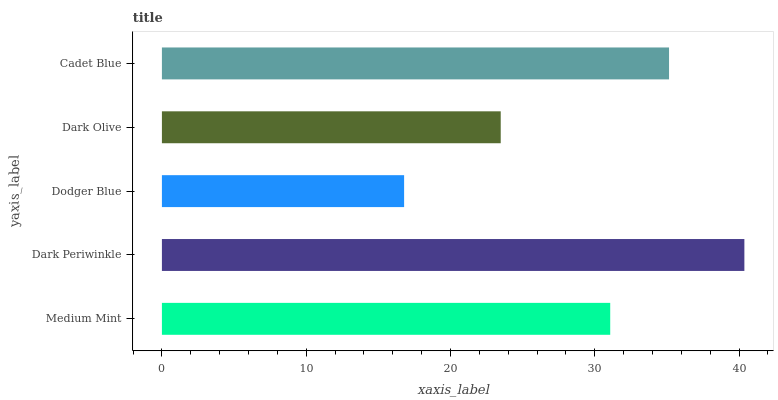Is Dodger Blue the minimum?
Answer yes or no. Yes. Is Dark Periwinkle the maximum?
Answer yes or no. Yes. Is Dark Periwinkle the minimum?
Answer yes or no. No. Is Dodger Blue the maximum?
Answer yes or no. No. Is Dark Periwinkle greater than Dodger Blue?
Answer yes or no. Yes. Is Dodger Blue less than Dark Periwinkle?
Answer yes or no. Yes. Is Dodger Blue greater than Dark Periwinkle?
Answer yes or no. No. Is Dark Periwinkle less than Dodger Blue?
Answer yes or no. No. Is Medium Mint the high median?
Answer yes or no. Yes. Is Medium Mint the low median?
Answer yes or no. Yes. Is Dark Periwinkle the high median?
Answer yes or no. No. Is Cadet Blue the low median?
Answer yes or no. No. 